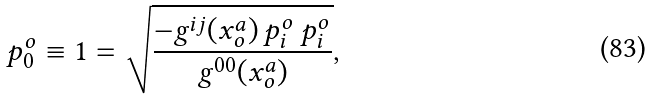Convert formula to latex. <formula><loc_0><loc_0><loc_500><loc_500>p _ { 0 } ^ { o } \equiv 1 = \sqrt { \frac { - g ^ { i j } ( x ^ { a } _ { o } ) \, p _ { i } ^ { o } \, p _ { i } ^ { o } } { g ^ { 0 0 } ( x ^ { a } _ { o } ) } } ,</formula> 